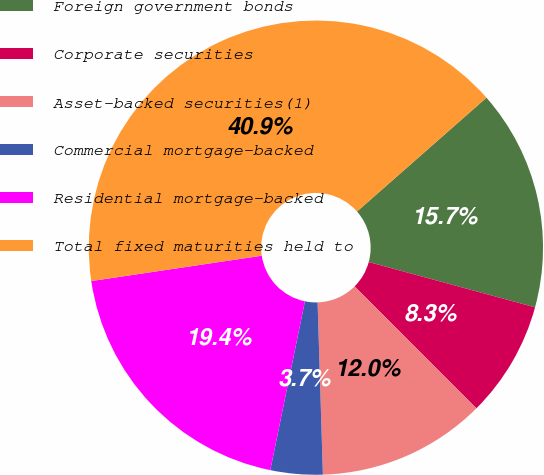Convert chart. <chart><loc_0><loc_0><loc_500><loc_500><pie_chart><fcel>Foreign government bonds<fcel>Corporate securities<fcel>Asset-backed securities(1)<fcel>Commercial mortgage-backed<fcel>Residential mortgage-backed<fcel>Total fixed maturities held to<nl><fcel>15.71%<fcel>8.28%<fcel>12.0%<fcel>3.71%<fcel>19.43%<fcel>40.87%<nl></chart> 